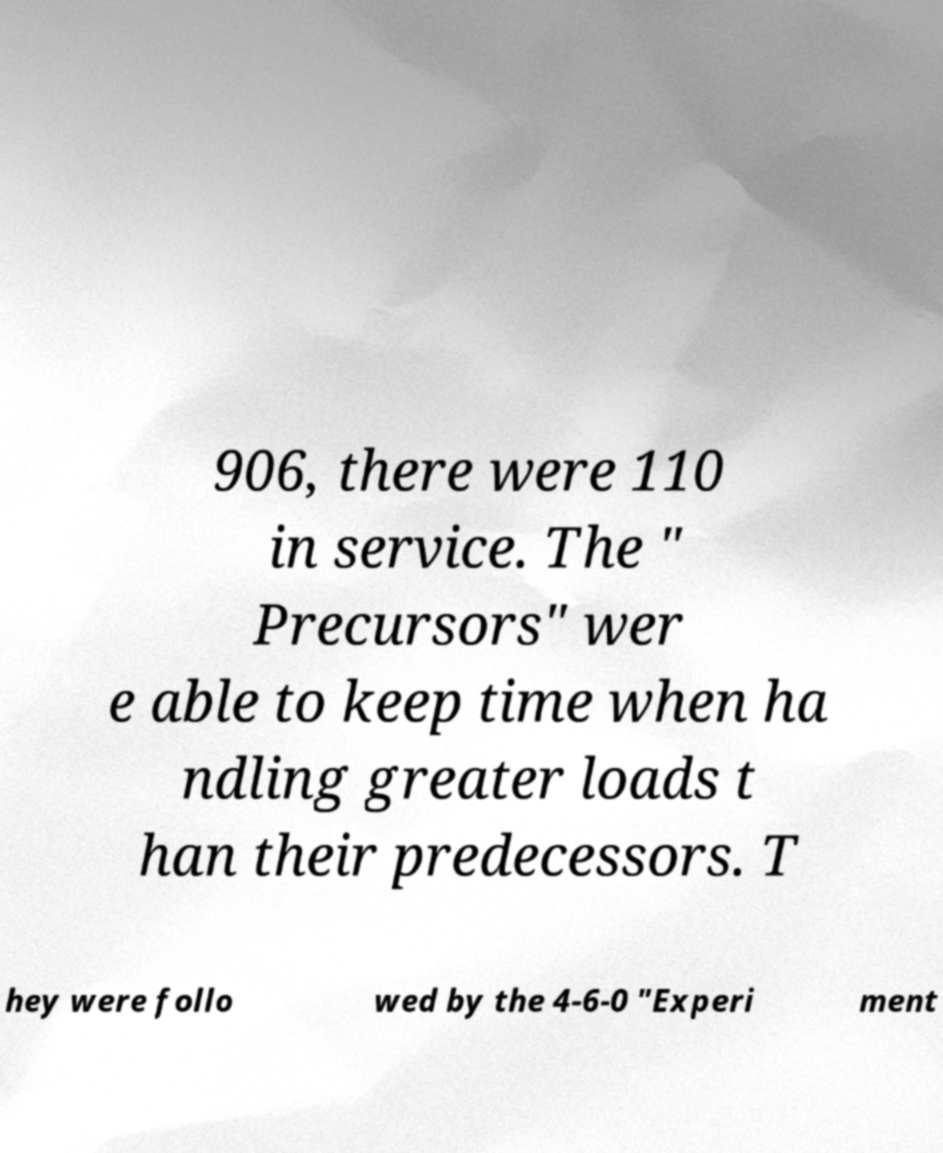Could you extract and type out the text from this image? 906, there were 110 in service. The " Precursors" wer e able to keep time when ha ndling greater loads t han their predecessors. T hey were follo wed by the 4-6-0 "Experi ment 